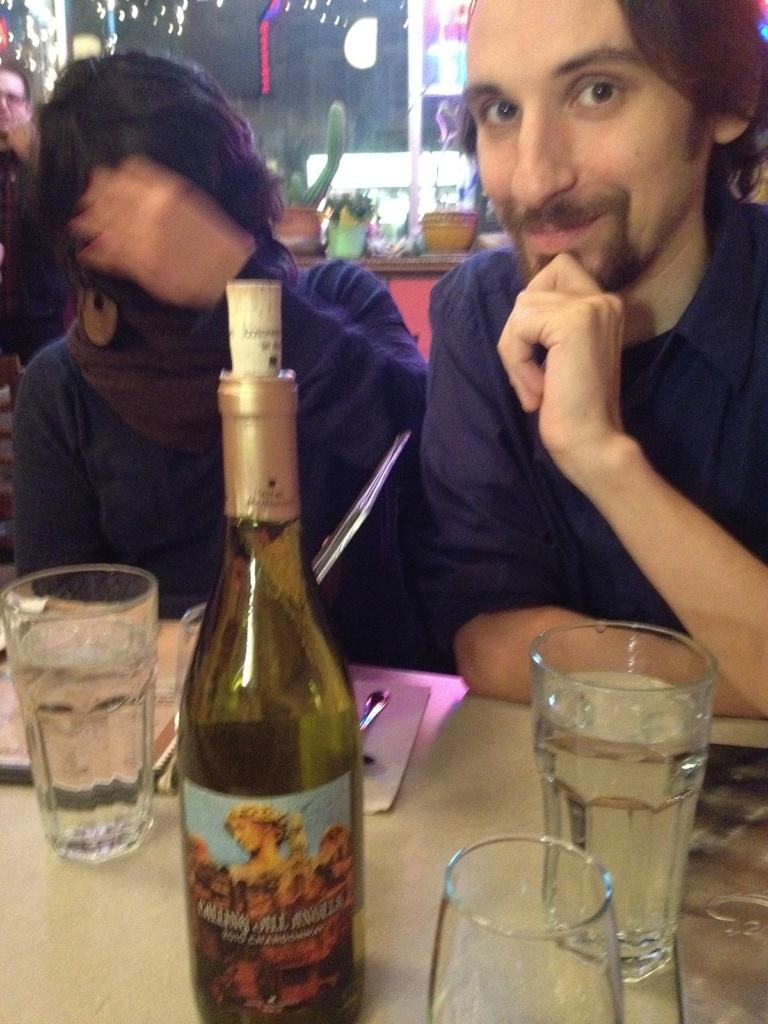Could you give a brief overview of what you see in this image? In this image i can see a bottle , three glasses on a table at the back ground i can see two persons sitting a small plant and a glass. 